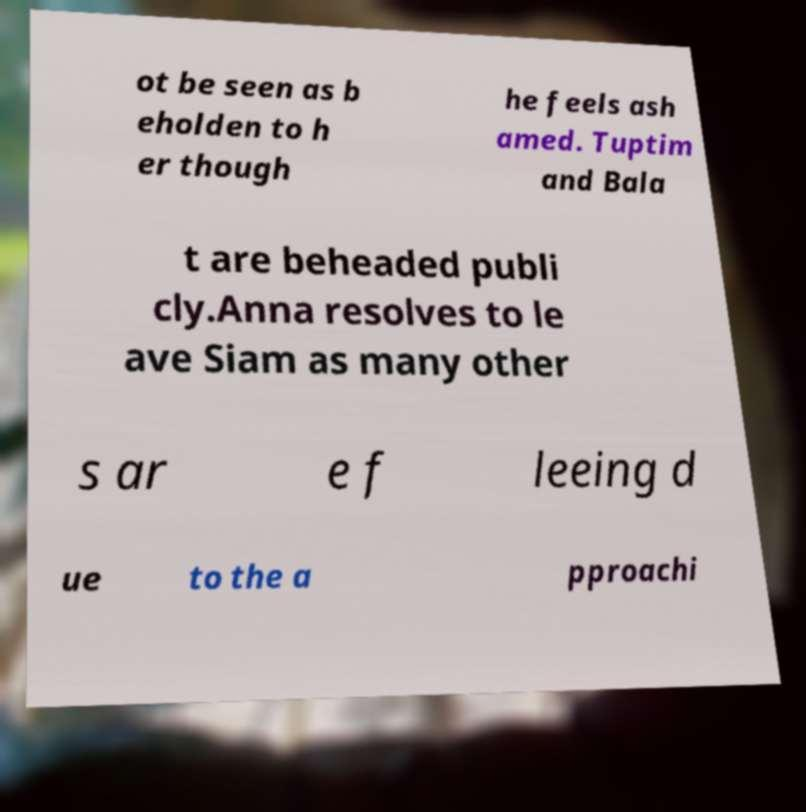There's text embedded in this image that I need extracted. Can you transcribe it verbatim? ot be seen as b eholden to h er though he feels ash amed. Tuptim and Bala t are beheaded publi cly.Anna resolves to le ave Siam as many other s ar e f leeing d ue to the a pproachi 